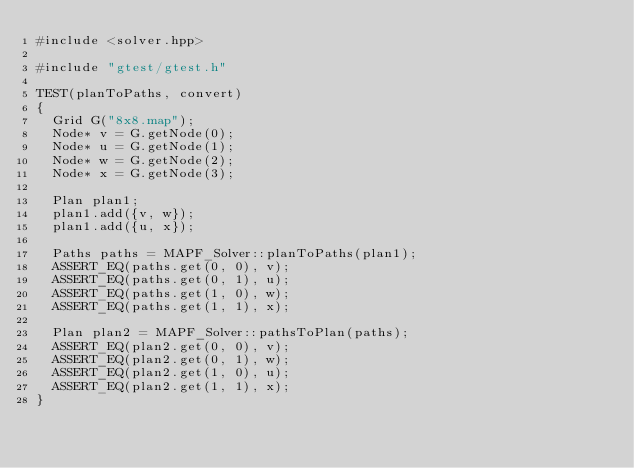<code> <loc_0><loc_0><loc_500><loc_500><_C++_>#include <solver.hpp>

#include "gtest/gtest.h"

TEST(planToPaths, convert)
{
  Grid G("8x8.map");
  Node* v = G.getNode(0);
  Node* u = G.getNode(1);
  Node* w = G.getNode(2);
  Node* x = G.getNode(3);

  Plan plan1;
  plan1.add({v, w});
  plan1.add({u, x});

  Paths paths = MAPF_Solver::planToPaths(plan1);
  ASSERT_EQ(paths.get(0, 0), v);
  ASSERT_EQ(paths.get(0, 1), u);
  ASSERT_EQ(paths.get(1, 0), w);
  ASSERT_EQ(paths.get(1, 1), x);

  Plan plan2 = MAPF_Solver::pathsToPlan(paths);
  ASSERT_EQ(plan2.get(0, 0), v);
  ASSERT_EQ(plan2.get(0, 1), w);
  ASSERT_EQ(plan2.get(1, 0), u);
  ASSERT_EQ(plan2.get(1, 1), x);
}
</code> 